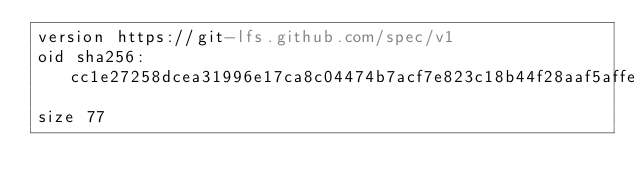Convert code to text. <code><loc_0><loc_0><loc_500><loc_500><_YAML_>version https://git-lfs.github.com/spec/v1
oid sha256:cc1e27258dcea31996e17ca8c04474b7acf7e823c18b44f28aaf5affe17382df
size 77
</code> 